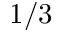Convert formula to latex. <formula><loc_0><loc_0><loc_500><loc_500>1 / 3</formula> 